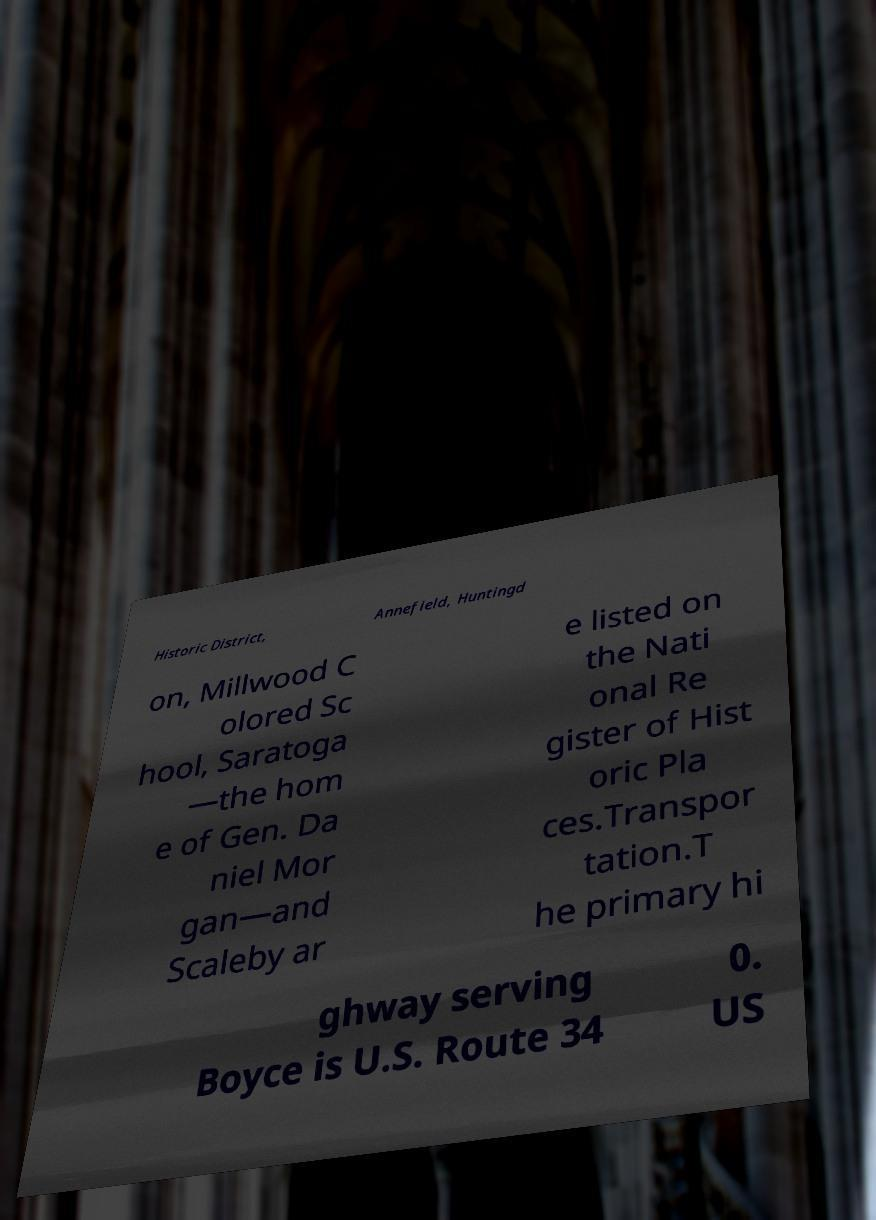Can you read and provide the text displayed in the image?This photo seems to have some interesting text. Can you extract and type it out for me? Historic District, Annefield, Huntingd on, Millwood C olored Sc hool, Saratoga —the hom e of Gen. Da niel Mor gan—and Scaleby ar e listed on the Nati onal Re gister of Hist oric Pla ces.Transpor tation.T he primary hi ghway serving Boyce is U.S. Route 34 0. US 